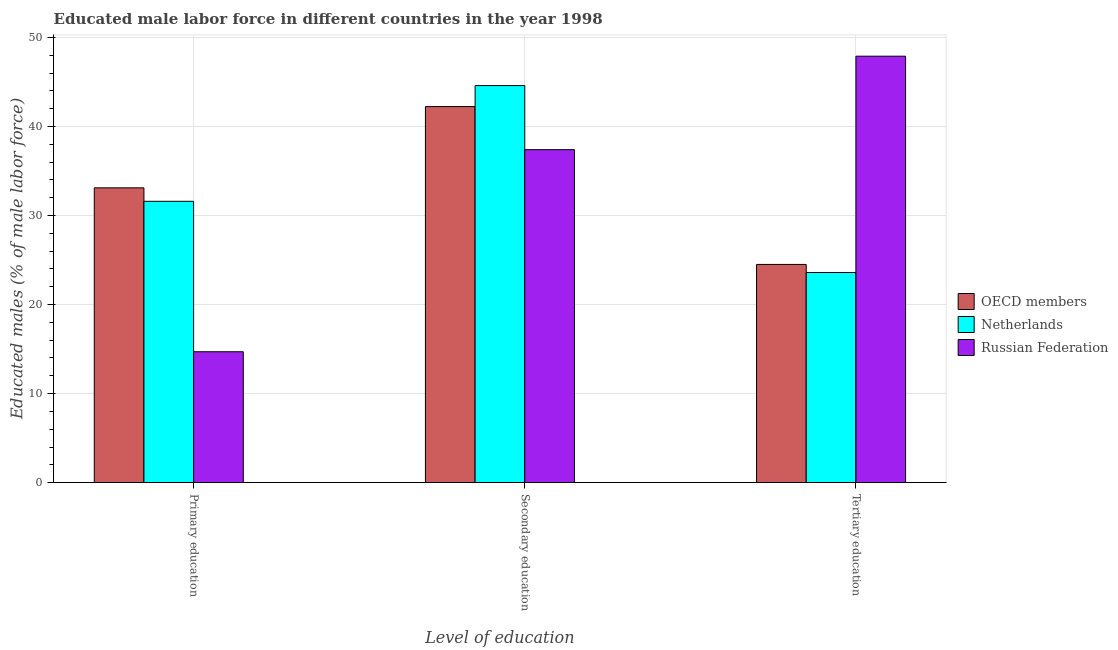How many different coloured bars are there?
Your answer should be compact. 3. How many groups of bars are there?
Offer a very short reply. 3. Are the number of bars per tick equal to the number of legend labels?
Provide a short and direct response. Yes. What is the label of the 2nd group of bars from the left?
Ensure brevity in your answer.  Secondary education. What is the percentage of male labor force who received secondary education in Netherlands?
Ensure brevity in your answer.  44.6. Across all countries, what is the maximum percentage of male labor force who received primary education?
Your answer should be very brief. 33.11. Across all countries, what is the minimum percentage of male labor force who received primary education?
Keep it short and to the point. 14.7. In which country was the percentage of male labor force who received primary education minimum?
Provide a short and direct response. Russian Federation. What is the total percentage of male labor force who received secondary education in the graph?
Your response must be concise. 124.24. What is the difference between the percentage of male labor force who received secondary education in Russian Federation and that in OECD members?
Offer a terse response. -4.84. What is the difference between the percentage of male labor force who received tertiary education in Netherlands and the percentage of male labor force who received primary education in Russian Federation?
Give a very brief answer. 8.9. What is the average percentage of male labor force who received secondary education per country?
Keep it short and to the point. 41.41. What is the difference between the percentage of male labor force who received tertiary education and percentage of male labor force who received secondary education in Netherlands?
Offer a very short reply. -21. What is the ratio of the percentage of male labor force who received primary education in OECD members to that in Netherlands?
Your answer should be very brief. 1.05. Is the difference between the percentage of male labor force who received primary education in Russian Federation and OECD members greater than the difference between the percentage of male labor force who received secondary education in Russian Federation and OECD members?
Make the answer very short. No. What is the difference between the highest and the second highest percentage of male labor force who received secondary education?
Provide a succinct answer. 2.36. What is the difference between the highest and the lowest percentage of male labor force who received tertiary education?
Make the answer very short. 24.3. Is the sum of the percentage of male labor force who received tertiary education in Russian Federation and OECD members greater than the maximum percentage of male labor force who received secondary education across all countries?
Your answer should be very brief. Yes. Are all the bars in the graph horizontal?
Your answer should be compact. No. How many countries are there in the graph?
Provide a short and direct response. 3. What is the difference between two consecutive major ticks on the Y-axis?
Offer a terse response. 10. Does the graph contain grids?
Provide a succinct answer. Yes. Where does the legend appear in the graph?
Your response must be concise. Center right. How are the legend labels stacked?
Offer a terse response. Vertical. What is the title of the graph?
Your response must be concise. Educated male labor force in different countries in the year 1998. Does "Myanmar" appear as one of the legend labels in the graph?
Provide a succinct answer. No. What is the label or title of the X-axis?
Keep it short and to the point. Level of education. What is the label or title of the Y-axis?
Provide a short and direct response. Educated males (% of male labor force). What is the Educated males (% of male labor force) in OECD members in Primary education?
Your answer should be very brief. 33.11. What is the Educated males (% of male labor force) of Netherlands in Primary education?
Offer a very short reply. 31.6. What is the Educated males (% of male labor force) of Russian Federation in Primary education?
Ensure brevity in your answer.  14.7. What is the Educated males (% of male labor force) of OECD members in Secondary education?
Ensure brevity in your answer.  42.24. What is the Educated males (% of male labor force) of Netherlands in Secondary education?
Make the answer very short. 44.6. What is the Educated males (% of male labor force) in Russian Federation in Secondary education?
Offer a terse response. 37.4. What is the Educated males (% of male labor force) of OECD members in Tertiary education?
Give a very brief answer. 24.51. What is the Educated males (% of male labor force) in Netherlands in Tertiary education?
Offer a very short reply. 23.6. What is the Educated males (% of male labor force) of Russian Federation in Tertiary education?
Ensure brevity in your answer.  47.9. Across all Level of education, what is the maximum Educated males (% of male labor force) in OECD members?
Your answer should be very brief. 42.24. Across all Level of education, what is the maximum Educated males (% of male labor force) of Netherlands?
Your answer should be compact. 44.6. Across all Level of education, what is the maximum Educated males (% of male labor force) of Russian Federation?
Provide a short and direct response. 47.9. Across all Level of education, what is the minimum Educated males (% of male labor force) of OECD members?
Give a very brief answer. 24.51. Across all Level of education, what is the minimum Educated males (% of male labor force) of Netherlands?
Give a very brief answer. 23.6. Across all Level of education, what is the minimum Educated males (% of male labor force) in Russian Federation?
Offer a very short reply. 14.7. What is the total Educated males (% of male labor force) of OECD members in the graph?
Provide a succinct answer. 99.86. What is the total Educated males (% of male labor force) of Netherlands in the graph?
Give a very brief answer. 99.8. What is the difference between the Educated males (% of male labor force) of OECD members in Primary education and that in Secondary education?
Your answer should be compact. -9.13. What is the difference between the Educated males (% of male labor force) in Russian Federation in Primary education and that in Secondary education?
Keep it short and to the point. -22.7. What is the difference between the Educated males (% of male labor force) in OECD members in Primary education and that in Tertiary education?
Offer a terse response. 8.6. What is the difference between the Educated males (% of male labor force) in Russian Federation in Primary education and that in Tertiary education?
Keep it short and to the point. -33.2. What is the difference between the Educated males (% of male labor force) in OECD members in Secondary education and that in Tertiary education?
Your answer should be compact. 17.73. What is the difference between the Educated males (% of male labor force) of Netherlands in Secondary education and that in Tertiary education?
Your answer should be very brief. 21. What is the difference between the Educated males (% of male labor force) in Russian Federation in Secondary education and that in Tertiary education?
Provide a succinct answer. -10.5. What is the difference between the Educated males (% of male labor force) in OECD members in Primary education and the Educated males (% of male labor force) in Netherlands in Secondary education?
Keep it short and to the point. -11.49. What is the difference between the Educated males (% of male labor force) in OECD members in Primary education and the Educated males (% of male labor force) in Russian Federation in Secondary education?
Your response must be concise. -4.29. What is the difference between the Educated males (% of male labor force) of OECD members in Primary education and the Educated males (% of male labor force) of Netherlands in Tertiary education?
Keep it short and to the point. 9.51. What is the difference between the Educated males (% of male labor force) in OECD members in Primary education and the Educated males (% of male labor force) in Russian Federation in Tertiary education?
Your response must be concise. -14.79. What is the difference between the Educated males (% of male labor force) in Netherlands in Primary education and the Educated males (% of male labor force) in Russian Federation in Tertiary education?
Your response must be concise. -16.3. What is the difference between the Educated males (% of male labor force) of OECD members in Secondary education and the Educated males (% of male labor force) of Netherlands in Tertiary education?
Offer a terse response. 18.64. What is the difference between the Educated males (% of male labor force) of OECD members in Secondary education and the Educated males (% of male labor force) of Russian Federation in Tertiary education?
Keep it short and to the point. -5.66. What is the difference between the Educated males (% of male labor force) of Netherlands in Secondary education and the Educated males (% of male labor force) of Russian Federation in Tertiary education?
Offer a terse response. -3.3. What is the average Educated males (% of male labor force) of OECD members per Level of education?
Your answer should be very brief. 33.29. What is the average Educated males (% of male labor force) in Netherlands per Level of education?
Your answer should be very brief. 33.27. What is the average Educated males (% of male labor force) of Russian Federation per Level of education?
Ensure brevity in your answer.  33.33. What is the difference between the Educated males (% of male labor force) of OECD members and Educated males (% of male labor force) of Netherlands in Primary education?
Your answer should be compact. 1.51. What is the difference between the Educated males (% of male labor force) in OECD members and Educated males (% of male labor force) in Russian Federation in Primary education?
Ensure brevity in your answer.  18.41. What is the difference between the Educated males (% of male labor force) of OECD members and Educated males (% of male labor force) of Netherlands in Secondary education?
Your response must be concise. -2.36. What is the difference between the Educated males (% of male labor force) in OECD members and Educated males (% of male labor force) in Russian Federation in Secondary education?
Keep it short and to the point. 4.84. What is the difference between the Educated males (% of male labor force) in OECD members and Educated males (% of male labor force) in Netherlands in Tertiary education?
Ensure brevity in your answer.  0.91. What is the difference between the Educated males (% of male labor force) in OECD members and Educated males (% of male labor force) in Russian Federation in Tertiary education?
Ensure brevity in your answer.  -23.39. What is the difference between the Educated males (% of male labor force) in Netherlands and Educated males (% of male labor force) in Russian Federation in Tertiary education?
Keep it short and to the point. -24.3. What is the ratio of the Educated males (% of male labor force) in OECD members in Primary education to that in Secondary education?
Your response must be concise. 0.78. What is the ratio of the Educated males (% of male labor force) of Netherlands in Primary education to that in Secondary education?
Keep it short and to the point. 0.71. What is the ratio of the Educated males (% of male labor force) in Russian Federation in Primary education to that in Secondary education?
Offer a terse response. 0.39. What is the ratio of the Educated males (% of male labor force) in OECD members in Primary education to that in Tertiary education?
Offer a very short reply. 1.35. What is the ratio of the Educated males (% of male labor force) in Netherlands in Primary education to that in Tertiary education?
Your response must be concise. 1.34. What is the ratio of the Educated males (% of male labor force) of Russian Federation in Primary education to that in Tertiary education?
Provide a succinct answer. 0.31. What is the ratio of the Educated males (% of male labor force) in OECD members in Secondary education to that in Tertiary education?
Make the answer very short. 1.72. What is the ratio of the Educated males (% of male labor force) of Netherlands in Secondary education to that in Tertiary education?
Offer a terse response. 1.89. What is the ratio of the Educated males (% of male labor force) of Russian Federation in Secondary education to that in Tertiary education?
Offer a terse response. 0.78. What is the difference between the highest and the second highest Educated males (% of male labor force) in OECD members?
Give a very brief answer. 9.13. What is the difference between the highest and the second highest Educated males (% of male labor force) in Netherlands?
Offer a terse response. 13. What is the difference between the highest and the lowest Educated males (% of male labor force) in OECD members?
Your answer should be compact. 17.73. What is the difference between the highest and the lowest Educated males (% of male labor force) of Netherlands?
Ensure brevity in your answer.  21. What is the difference between the highest and the lowest Educated males (% of male labor force) of Russian Federation?
Give a very brief answer. 33.2. 